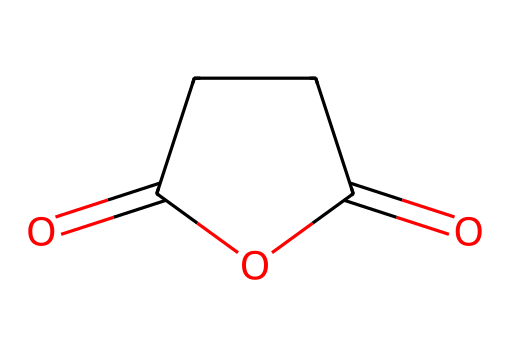What is the IUPAC name of this compound? The SMILES representation denotes a cyclic structure with specific functional groups. The compound contains an anhydride functional group, formed from the dicarboxylic acid succinic acid by dehydration. Therefore, it is named succinic anhydride.
Answer: succinic anhydride How many carbon atoms are in this molecule? Analyzing the SMILES representation shows that there are four carbon atoms in the ring structure as indicated by the 'C' notations.
Answer: 4 How many oxygen atoms are present in this molecule? In the chemical structure, there are four 'O' notations visible in the SMILES, indicating the presence of four oxygen atoms within the molecule.
Answer: 4 What type of functional groups are indicated in this chemical? The SMILES indicates the presence of an anhydride group (two carbonyl groups with a bridging oxygen) alongside the molecular structure, which classifies it as an anhydride.
Answer: anhydride What is the molecular formula of succinic anhydride? By combining the number of each type of atom (C, H, and O) based on the visualized structure: 4 carbons, 4 oxygens, and 4 hydrogens yield the molecular formula C4H4O3.
Answer: C4H4O3 Why is succinic anhydride used in pharmaceuticals? The cyclic anhydride structure allows for easy reactivity with nucleophiles, making it useful in creating esters and amides, which are critical in drug development.
Answer: reactivity with nucleophiles 